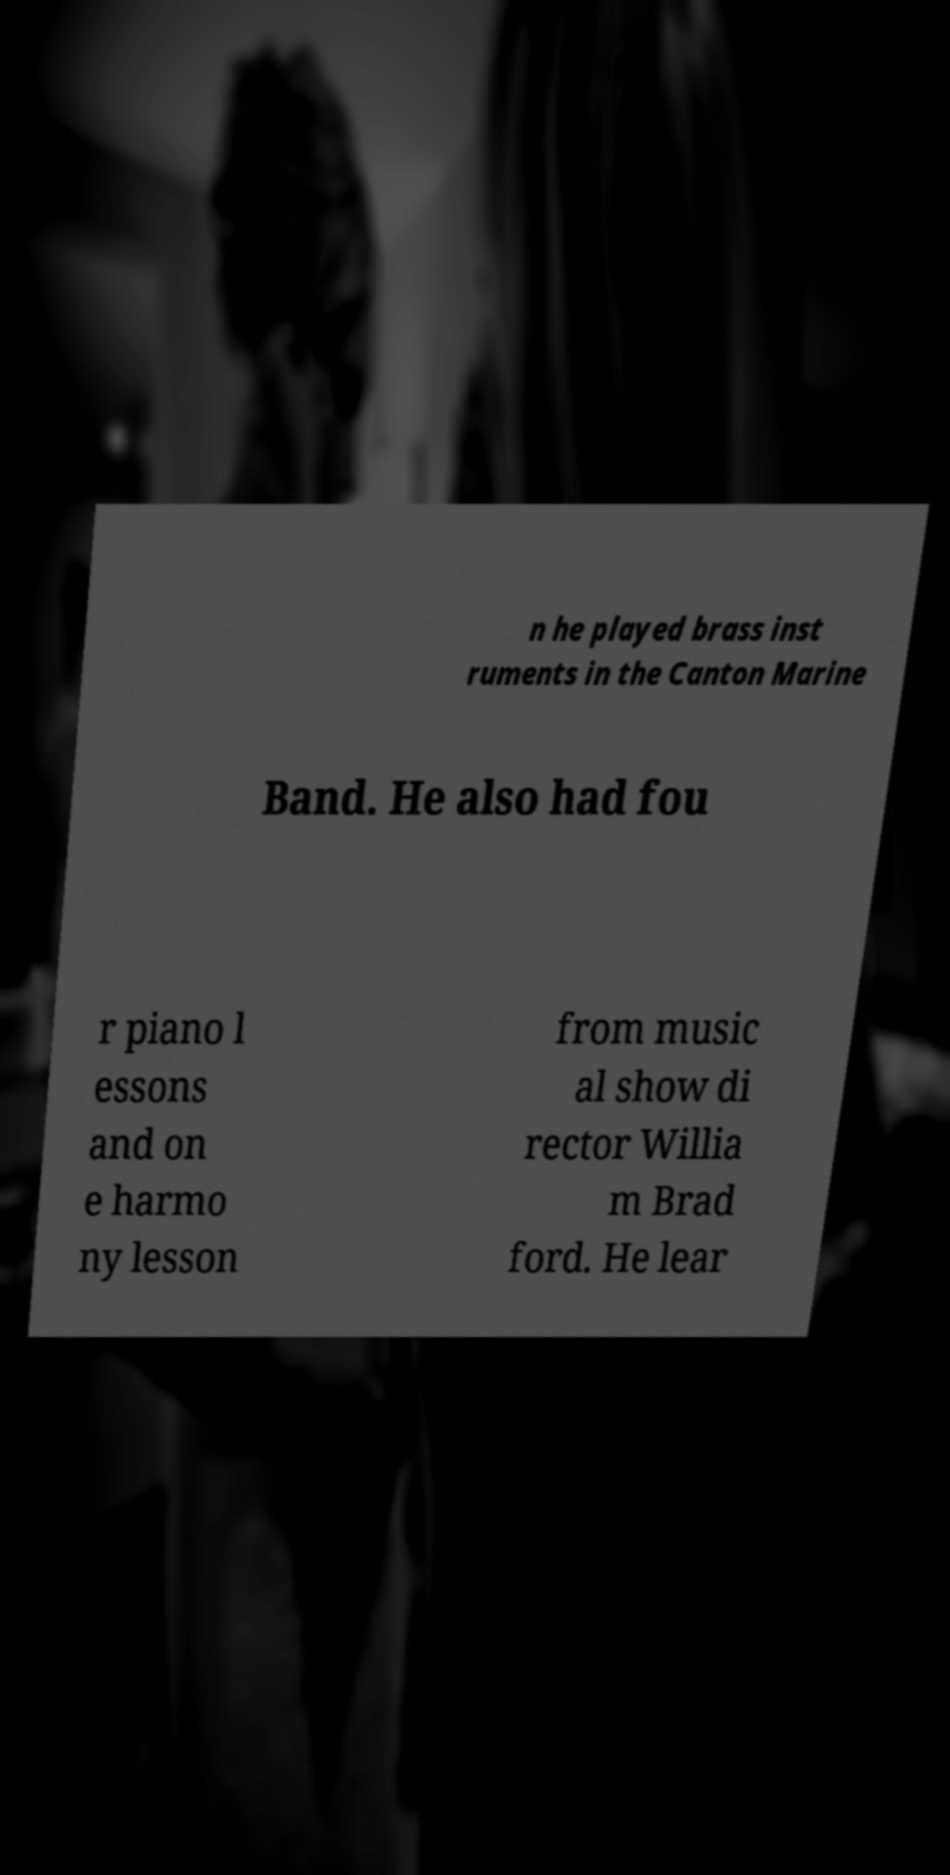There's text embedded in this image that I need extracted. Can you transcribe it verbatim? n he played brass inst ruments in the Canton Marine Band. He also had fou r piano l essons and on e harmo ny lesson from music al show di rector Willia m Brad ford. He lear 